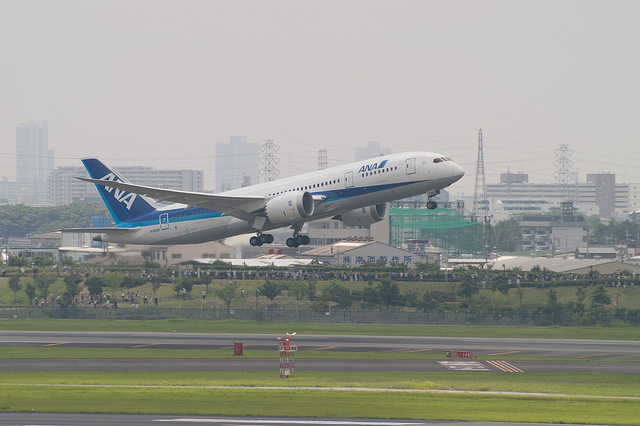<image>Can the airplane carry more passengers? It's unknown if the airplane can carry more passengers. It might depend on a variety of factors. Can the airplane carry more passengers? I don't know if the airplane can carry more passengers. 